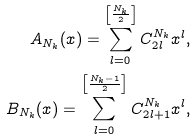<formula> <loc_0><loc_0><loc_500><loc_500>A _ { N _ { k } } ( x ) = \sum _ { l = 0 } ^ { \left [ \frac { N _ { k } } { 2 } \right ] } C _ { 2 l } ^ { N _ { k } } x ^ { l } , \\ B _ { N _ { k } } ( x ) = \sum _ { l = 0 } ^ { \left [ \frac { N _ { k } - 1 } { 2 } \right ] } C _ { 2 l + 1 } ^ { N _ { k } } x ^ { l } ,</formula> 